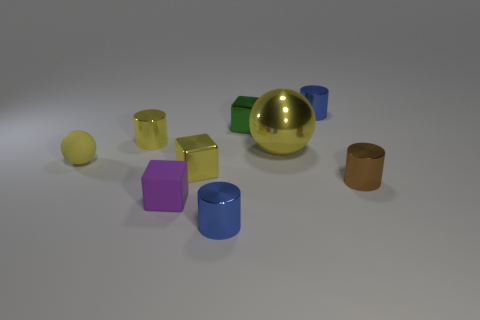What materials do the objects in the image seem to be made of, based on their appearances? The objects appear to be made of different materials. The large ball in the center has a reflective gold surface suggesting a metallic material. The blue object on the right looks shiny and could be ceramic or glass. The rubber-like items have a matte finish, possibly indicating a plastic composition. 